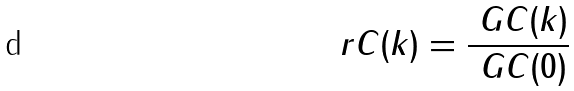<formula> <loc_0><loc_0><loc_500><loc_500>\ r C ( k ) = \frac { \ G C ( k ) } { \ G C ( 0 ) }</formula> 